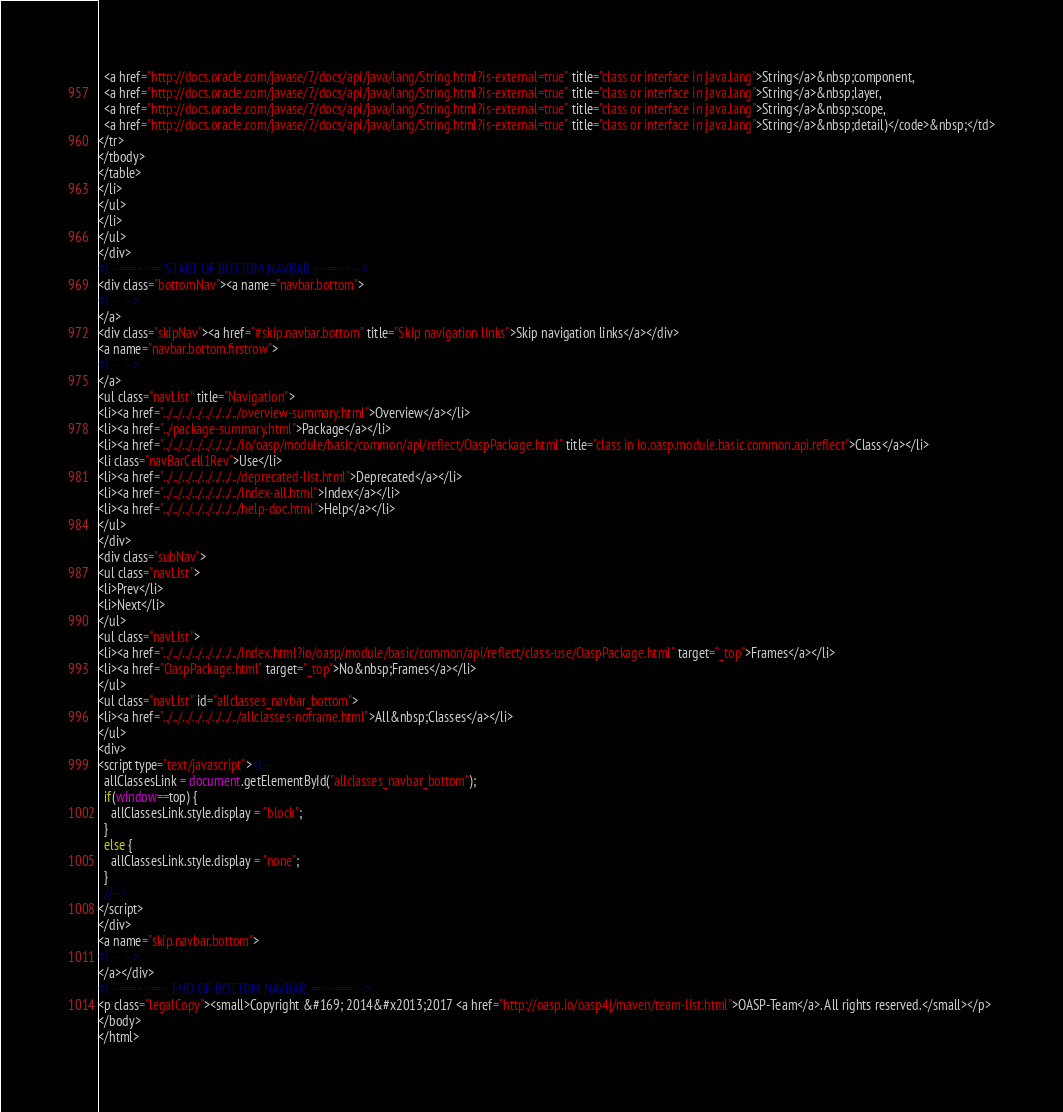Convert code to text. <code><loc_0><loc_0><loc_500><loc_500><_HTML_>  <a href="http://docs.oracle.com/javase/7/docs/api/java/lang/String.html?is-external=true" title="class or interface in java.lang">String</a>&nbsp;component,
  <a href="http://docs.oracle.com/javase/7/docs/api/java/lang/String.html?is-external=true" title="class or interface in java.lang">String</a>&nbsp;layer,
  <a href="http://docs.oracle.com/javase/7/docs/api/java/lang/String.html?is-external=true" title="class or interface in java.lang">String</a>&nbsp;scope,
  <a href="http://docs.oracle.com/javase/7/docs/api/java/lang/String.html?is-external=true" title="class or interface in java.lang">String</a>&nbsp;detail)</code>&nbsp;</td>
</tr>
</tbody>
</table>
</li>
</ul>
</li>
</ul>
</div>
<!-- ======= START OF BOTTOM NAVBAR ====== -->
<div class="bottomNav"><a name="navbar.bottom">
<!--   -->
</a>
<div class="skipNav"><a href="#skip.navbar.bottom" title="Skip navigation links">Skip navigation links</a></div>
<a name="navbar.bottom.firstrow">
<!--   -->
</a>
<ul class="navList" title="Navigation">
<li><a href="../../../../../../../../overview-summary.html">Overview</a></li>
<li><a href="../package-summary.html">Package</a></li>
<li><a href="../../../../../../../../io/oasp/module/basic/common/api/reflect/OaspPackage.html" title="class in io.oasp.module.basic.common.api.reflect">Class</a></li>
<li class="navBarCell1Rev">Use</li>
<li><a href="../../../../../../../../deprecated-list.html">Deprecated</a></li>
<li><a href="../../../../../../../../index-all.html">Index</a></li>
<li><a href="../../../../../../../../help-doc.html">Help</a></li>
</ul>
</div>
<div class="subNav">
<ul class="navList">
<li>Prev</li>
<li>Next</li>
</ul>
<ul class="navList">
<li><a href="../../../../../../../../index.html?io/oasp/module/basic/common/api/reflect/class-use/OaspPackage.html" target="_top">Frames</a></li>
<li><a href="OaspPackage.html" target="_top">No&nbsp;Frames</a></li>
</ul>
<ul class="navList" id="allclasses_navbar_bottom">
<li><a href="../../../../../../../../allclasses-noframe.html">All&nbsp;Classes</a></li>
</ul>
<div>
<script type="text/javascript"><!--
  allClassesLink = document.getElementById("allclasses_navbar_bottom");
  if(window==top) {
    allClassesLink.style.display = "block";
  }
  else {
    allClassesLink.style.display = "none";
  }
  //-->
</script>
</div>
<a name="skip.navbar.bottom">
<!--   -->
</a></div>
<!-- ======== END OF BOTTOM NAVBAR ======= -->
<p class="legalCopy"><small>Copyright &#169; 2014&#x2013;2017 <a href="http://oasp.io/oasp4j/maven/team-list.html">OASP-Team</a>. All rights reserved.</small></p>
</body>
</html>
</code> 